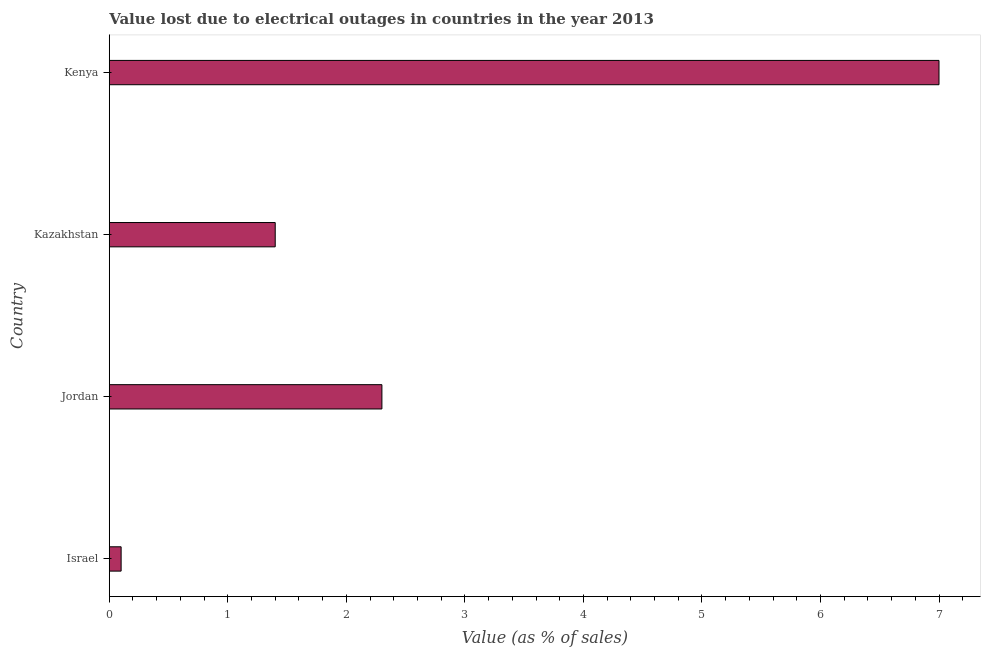What is the title of the graph?
Offer a very short reply. Value lost due to electrical outages in countries in the year 2013. What is the label or title of the X-axis?
Offer a terse response. Value (as % of sales). What is the value lost due to electrical outages in Kenya?
Give a very brief answer. 7. Across all countries, what is the maximum value lost due to electrical outages?
Make the answer very short. 7. In which country was the value lost due to electrical outages maximum?
Provide a short and direct response. Kenya. In which country was the value lost due to electrical outages minimum?
Offer a terse response. Israel. What is the sum of the value lost due to electrical outages?
Your answer should be compact. 10.8. What is the median value lost due to electrical outages?
Your response must be concise. 1.85. What is the ratio of the value lost due to electrical outages in Israel to that in Kenya?
Ensure brevity in your answer.  0.01. Is the value lost due to electrical outages in Kazakhstan less than that in Kenya?
Your answer should be very brief. Yes. What is the difference between the highest and the second highest value lost due to electrical outages?
Give a very brief answer. 4.7. Is the sum of the value lost due to electrical outages in Israel and Kenya greater than the maximum value lost due to electrical outages across all countries?
Your answer should be very brief. Yes. In how many countries, is the value lost due to electrical outages greater than the average value lost due to electrical outages taken over all countries?
Offer a very short reply. 1. How many countries are there in the graph?
Your answer should be compact. 4. What is the Value (as % of sales) in Kazakhstan?
Make the answer very short. 1.4. What is the Value (as % of sales) of Kenya?
Provide a succinct answer. 7. What is the difference between the Value (as % of sales) in Israel and Kenya?
Keep it short and to the point. -6.9. What is the difference between the Value (as % of sales) in Jordan and Kazakhstan?
Give a very brief answer. 0.9. What is the ratio of the Value (as % of sales) in Israel to that in Jordan?
Make the answer very short. 0.04. What is the ratio of the Value (as % of sales) in Israel to that in Kazakhstan?
Make the answer very short. 0.07. What is the ratio of the Value (as % of sales) in Israel to that in Kenya?
Provide a succinct answer. 0.01. What is the ratio of the Value (as % of sales) in Jordan to that in Kazakhstan?
Offer a very short reply. 1.64. What is the ratio of the Value (as % of sales) in Jordan to that in Kenya?
Offer a terse response. 0.33. What is the ratio of the Value (as % of sales) in Kazakhstan to that in Kenya?
Make the answer very short. 0.2. 